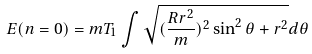Convert formula to latex. <formula><loc_0><loc_0><loc_500><loc_500>E ( n = 0 ) = m T _ { 1 } \int \sqrt { ( \frac { R r ^ { 2 } } { m } ) ^ { 2 } \sin ^ { 2 } \theta + r ^ { 2 } } d \theta</formula> 